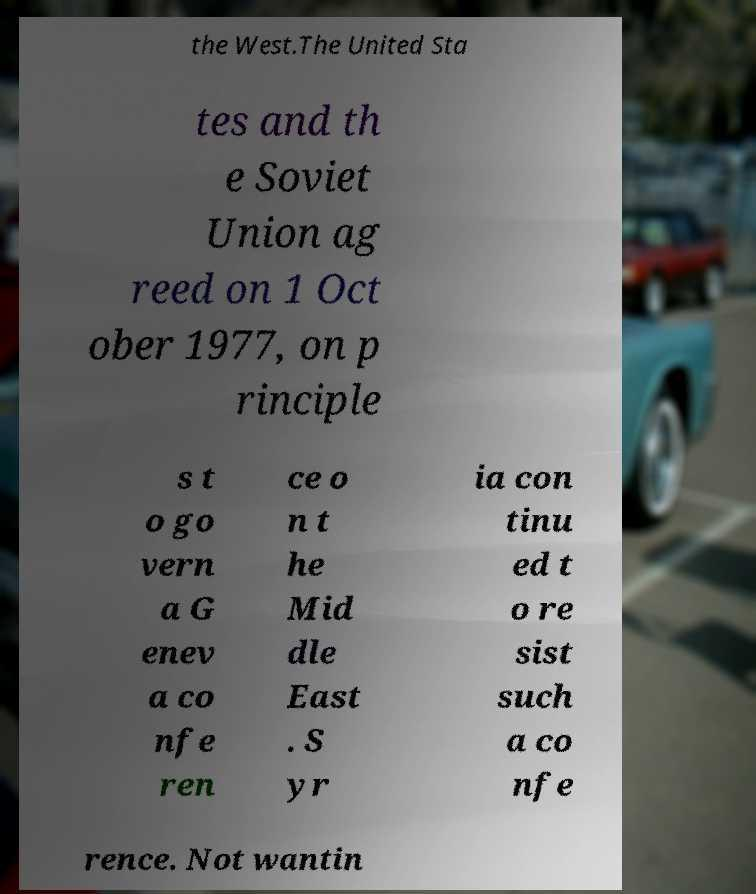For documentation purposes, I need the text within this image transcribed. Could you provide that? the West.The United Sta tes and th e Soviet Union ag reed on 1 Oct ober 1977, on p rinciple s t o go vern a G enev a co nfe ren ce o n t he Mid dle East . S yr ia con tinu ed t o re sist such a co nfe rence. Not wantin 